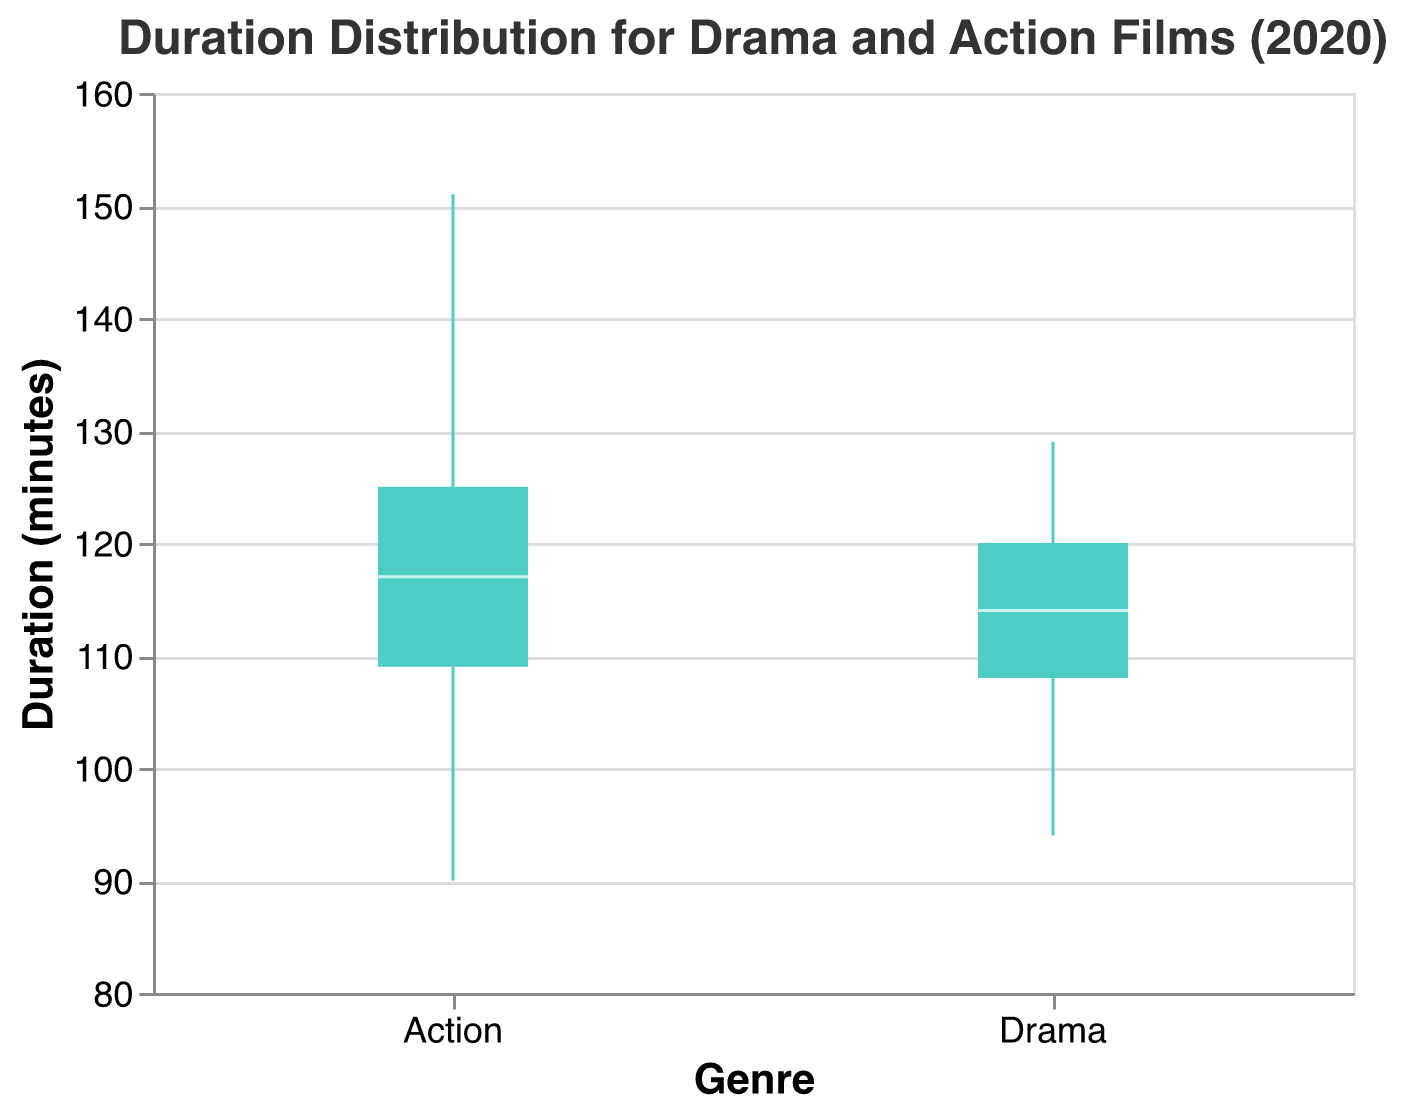What is the title of the figure? The title is displayed at the top of the figure and reads "Duration Distribution for Drama and Action Films (2020)"
Answer: Duration Distribution for Drama and Action Films (2020) What are the two genres compared in the box plot? The x-axis labels indicate the two genres being compared in the box plot: "Drama" and "Action"
Answer: Drama and Action What is the range of durations for Action films? The range can be observed from the spread of the box plot for Action films, from the minimum whisker to the maximum whisker. It ranges from 90 to 151 minutes.
Answer: 90 to 151 minutes Which genre has the higher median duration? The median is represented by the horizontal line within each box. The Action genre has a higher median duration compared to Drama.
Answer: Action What is the duration range for Drama films? Look at the spread of the Drama box plot, which extends from the minimum whisker at 94 minutes to the maximum whisker at 129 minutes.
Answer: 94 to 129 minutes What is the median duration for Drama films? The median for Drama films is indicated by the horizontal line within the Drama box, which is around 114 minutes.
Answer: 114 minutes Which film has the maximum duration in the Action genre? The maximum value in the Action box plot is 151 minutes, corresponding to the film "Wonder Woman 1984".
Answer: Wonder Woman 1984 Which genre has a wider interquartile range (IQR)? The IQR is represented by the height of the box. The Action genre has a wider IQR than the Drama genre.
Answer: Action Are there any outliers in the Drama genre? Outliers would be points outside the whiskers, but there are no such points in the Drama box plot.
Answer: No What is the duration of the shortest film in the Action genre? The minimum whisker in the Action box plot indicates the shortest film's duration, which is 90 minutes, corresponding to "The Hunt".
Answer: 90 minutes 